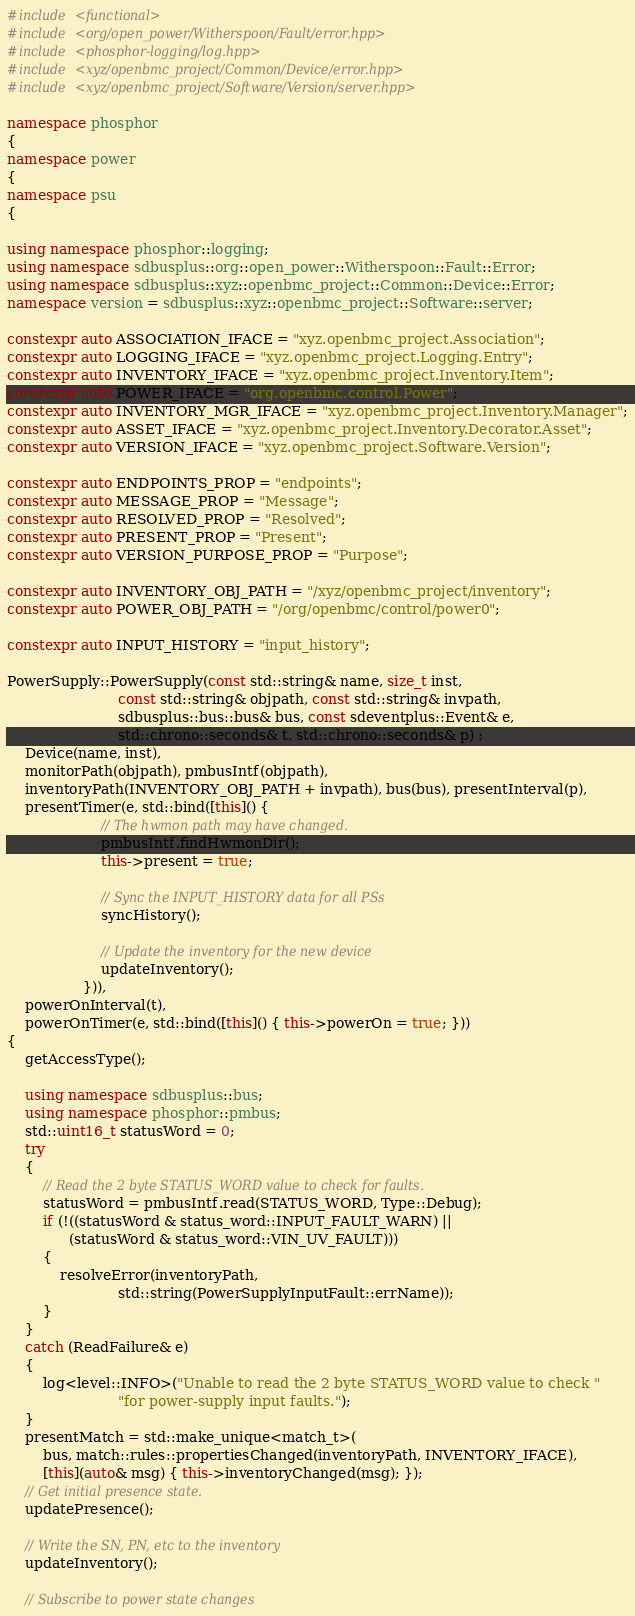<code> <loc_0><loc_0><loc_500><loc_500><_C++_>#include <functional>
#include <org/open_power/Witherspoon/Fault/error.hpp>
#include <phosphor-logging/log.hpp>
#include <xyz/openbmc_project/Common/Device/error.hpp>
#include <xyz/openbmc_project/Software/Version/server.hpp>

namespace phosphor
{
namespace power
{
namespace psu
{

using namespace phosphor::logging;
using namespace sdbusplus::org::open_power::Witherspoon::Fault::Error;
using namespace sdbusplus::xyz::openbmc_project::Common::Device::Error;
namespace version = sdbusplus::xyz::openbmc_project::Software::server;

constexpr auto ASSOCIATION_IFACE = "xyz.openbmc_project.Association";
constexpr auto LOGGING_IFACE = "xyz.openbmc_project.Logging.Entry";
constexpr auto INVENTORY_IFACE = "xyz.openbmc_project.Inventory.Item";
constexpr auto POWER_IFACE = "org.openbmc.control.Power";
constexpr auto INVENTORY_MGR_IFACE = "xyz.openbmc_project.Inventory.Manager";
constexpr auto ASSET_IFACE = "xyz.openbmc_project.Inventory.Decorator.Asset";
constexpr auto VERSION_IFACE = "xyz.openbmc_project.Software.Version";

constexpr auto ENDPOINTS_PROP = "endpoints";
constexpr auto MESSAGE_PROP = "Message";
constexpr auto RESOLVED_PROP = "Resolved";
constexpr auto PRESENT_PROP = "Present";
constexpr auto VERSION_PURPOSE_PROP = "Purpose";

constexpr auto INVENTORY_OBJ_PATH = "/xyz/openbmc_project/inventory";
constexpr auto POWER_OBJ_PATH = "/org/openbmc/control/power0";

constexpr auto INPUT_HISTORY = "input_history";

PowerSupply::PowerSupply(const std::string& name, size_t inst,
                         const std::string& objpath, const std::string& invpath,
                         sdbusplus::bus::bus& bus, const sdeventplus::Event& e,
                         std::chrono::seconds& t, std::chrono::seconds& p) :
    Device(name, inst),
    monitorPath(objpath), pmbusIntf(objpath),
    inventoryPath(INVENTORY_OBJ_PATH + invpath), bus(bus), presentInterval(p),
    presentTimer(e, std::bind([this]() {
                     // The hwmon path may have changed.
                     pmbusIntf.findHwmonDir();
                     this->present = true;

                     // Sync the INPUT_HISTORY data for all PSs
                     syncHistory();

                     // Update the inventory for the new device
                     updateInventory();
                 })),
    powerOnInterval(t),
    powerOnTimer(e, std::bind([this]() { this->powerOn = true; }))
{
    getAccessType();

    using namespace sdbusplus::bus;
    using namespace phosphor::pmbus;
    std::uint16_t statusWord = 0;
    try
    {
        // Read the 2 byte STATUS_WORD value to check for faults.
        statusWord = pmbusIntf.read(STATUS_WORD, Type::Debug);
        if (!((statusWord & status_word::INPUT_FAULT_WARN) ||
              (statusWord & status_word::VIN_UV_FAULT)))
        {
            resolveError(inventoryPath,
                         std::string(PowerSupplyInputFault::errName));
        }
    }
    catch (ReadFailure& e)
    {
        log<level::INFO>("Unable to read the 2 byte STATUS_WORD value to check "
                         "for power-supply input faults.");
    }
    presentMatch = std::make_unique<match_t>(
        bus, match::rules::propertiesChanged(inventoryPath, INVENTORY_IFACE),
        [this](auto& msg) { this->inventoryChanged(msg); });
    // Get initial presence state.
    updatePresence();

    // Write the SN, PN, etc to the inventory
    updateInventory();

    // Subscribe to power state changes</code> 